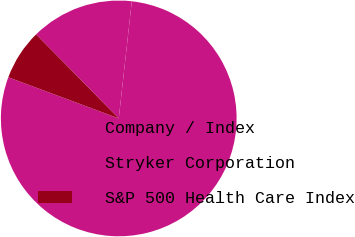<chart> <loc_0><loc_0><loc_500><loc_500><pie_chart><fcel>Company / Index<fcel>Stryker Corporation<fcel>S&P 500 Health Care Index<nl><fcel>78.91%<fcel>14.14%<fcel>6.95%<nl></chart> 